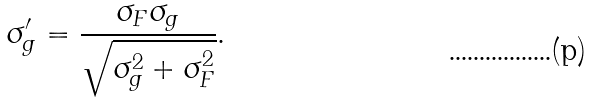<formula> <loc_0><loc_0><loc_500><loc_500>\sigma _ { g } ^ { \prime } = \frac { \sigma _ { F } \sigma _ { g } } { \sqrt { \sigma _ { g } ^ { 2 } + \sigma _ { F } ^ { 2 } } } \text {.}</formula> 